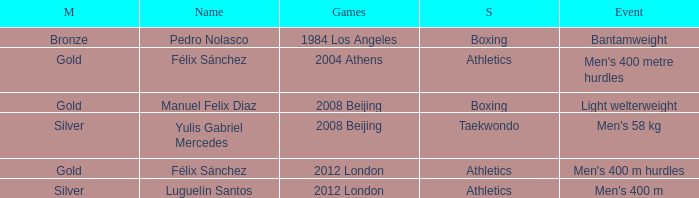What Medal had a Name of manuel felix diaz? Gold. 